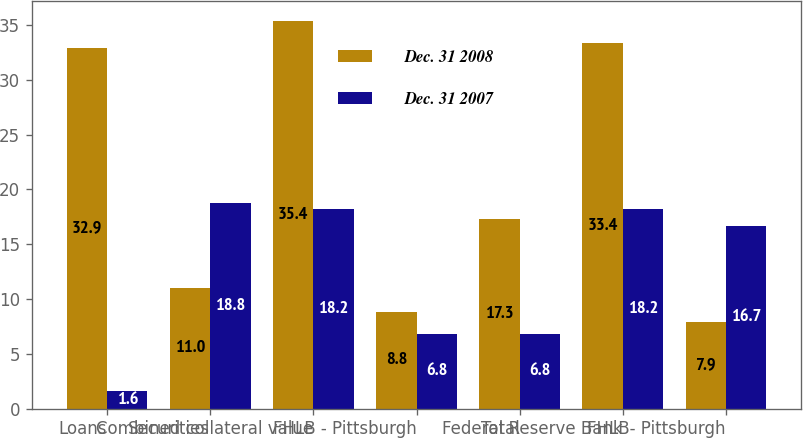<chart> <loc_0><loc_0><loc_500><loc_500><stacked_bar_chart><ecel><fcel>Loans<fcel>Securities<fcel>Combined collateral value<fcel>FHLB - Pittsburgh<fcel>Total<fcel>Federal Reserve Bank<fcel>FHLB- Pittsburgh<nl><fcel>Dec. 31 2008<fcel>32.9<fcel>11<fcel>35.4<fcel>8.8<fcel>17.3<fcel>33.4<fcel>7.9<nl><fcel>Dec. 31 2007<fcel>1.6<fcel>18.8<fcel>18.2<fcel>6.8<fcel>6.8<fcel>18.2<fcel>16.7<nl></chart> 